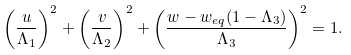Convert formula to latex. <formula><loc_0><loc_0><loc_500><loc_500>\left ( \frac { u } { \Lambda _ { 1 } } \right ) ^ { 2 } + \left ( \frac { v } { \Lambda _ { 2 } } \right ) ^ { 2 } + \left ( \frac { w - w _ { e q } ( 1 - \Lambda _ { 3 } ) } { \Lambda _ { 3 } } \right ) ^ { 2 } = 1 .</formula> 